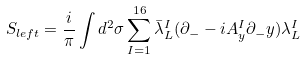<formula> <loc_0><loc_0><loc_500><loc_500>S _ { l e f t } = \frac { i } { \pi } \int d ^ { 2 } \sigma \sum _ { I = 1 } ^ { 1 6 } \bar { \lambda } _ { L } ^ { I } ( \partial _ { - } - i A _ { y } ^ { I } \partial _ { - } y ) \lambda _ { L } ^ { I }</formula> 